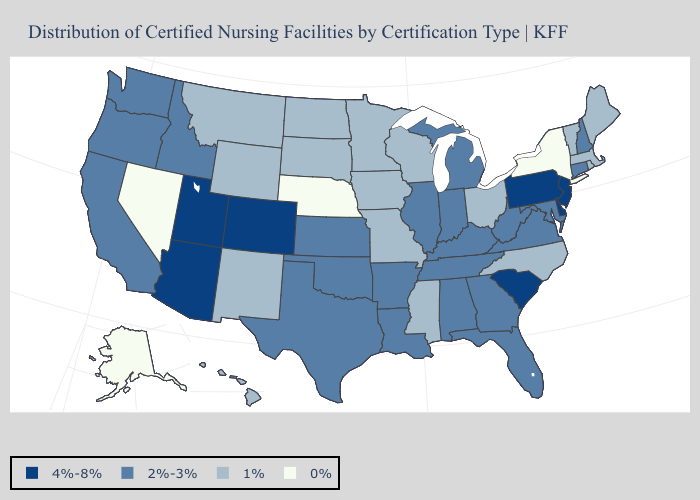What is the highest value in states that border Virginia?
Quick response, please. 2%-3%. Which states hav the highest value in the South?
Keep it brief. Delaware, South Carolina. Name the states that have a value in the range 0%?
Concise answer only. Alaska, Nebraska, Nevada, New York. Name the states that have a value in the range 1%?
Answer briefly. Hawaii, Iowa, Maine, Massachusetts, Minnesota, Mississippi, Missouri, Montana, New Mexico, North Carolina, North Dakota, Ohio, Rhode Island, South Dakota, Vermont, Wisconsin, Wyoming. Name the states that have a value in the range 4%-8%?
Be succinct. Arizona, Colorado, Delaware, New Jersey, Pennsylvania, South Carolina, Utah. What is the lowest value in states that border West Virginia?
Concise answer only. 1%. Does Indiana have the highest value in the USA?
Quick response, please. No. What is the value of Massachusetts?
Short answer required. 1%. Which states have the highest value in the USA?
Keep it brief. Arizona, Colorado, Delaware, New Jersey, Pennsylvania, South Carolina, Utah. Name the states that have a value in the range 0%?
Be succinct. Alaska, Nebraska, Nevada, New York. Does Pennsylvania have the highest value in the USA?
Give a very brief answer. Yes. Does Illinois have the highest value in the MidWest?
Give a very brief answer. Yes. What is the value of Rhode Island?
Write a very short answer. 1%. Does New York have the lowest value in the Northeast?
Write a very short answer. Yes. Name the states that have a value in the range 2%-3%?
Give a very brief answer. Alabama, Arkansas, California, Connecticut, Florida, Georgia, Idaho, Illinois, Indiana, Kansas, Kentucky, Louisiana, Maryland, Michigan, New Hampshire, Oklahoma, Oregon, Tennessee, Texas, Virginia, Washington, West Virginia. 